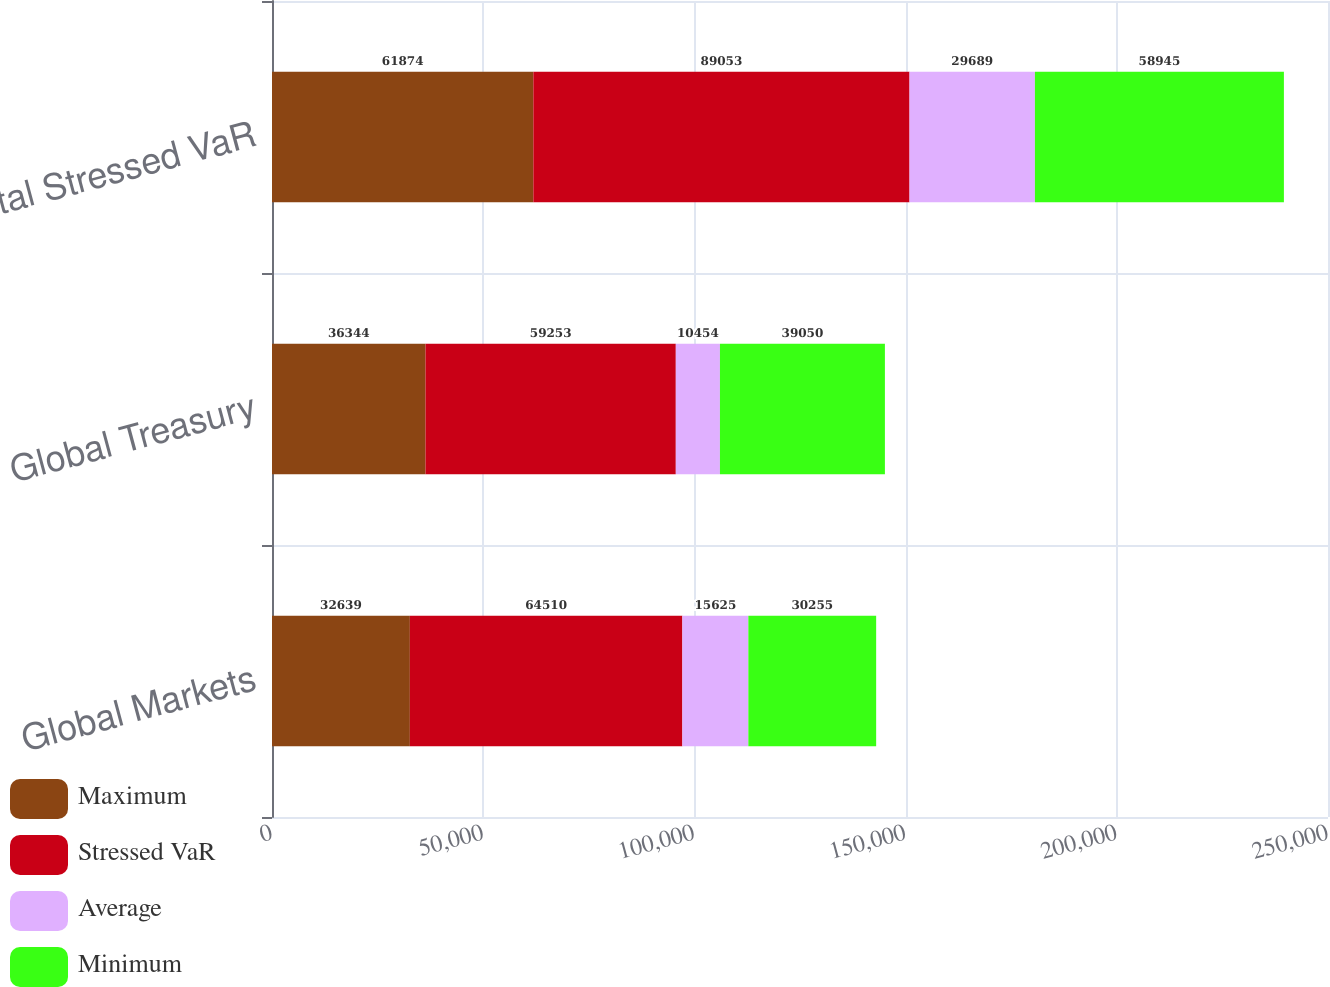Convert chart to OTSL. <chart><loc_0><loc_0><loc_500><loc_500><stacked_bar_chart><ecel><fcel>Global Markets<fcel>Global Treasury<fcel>Total Stressed VaR<nl><fcel>Maximum<fcel>32639<fcel>36344<fcel>61874<nl><fcel>Stressed VaR<fcel>64510<fcel>59253<fcel>89053<nl><fcel>Average<fcel>15625<fcel>10454<fcel>29689<nl><fcel>Minimum<fcel>30255<fcel>39050<fcel>58945<nl></chart> 